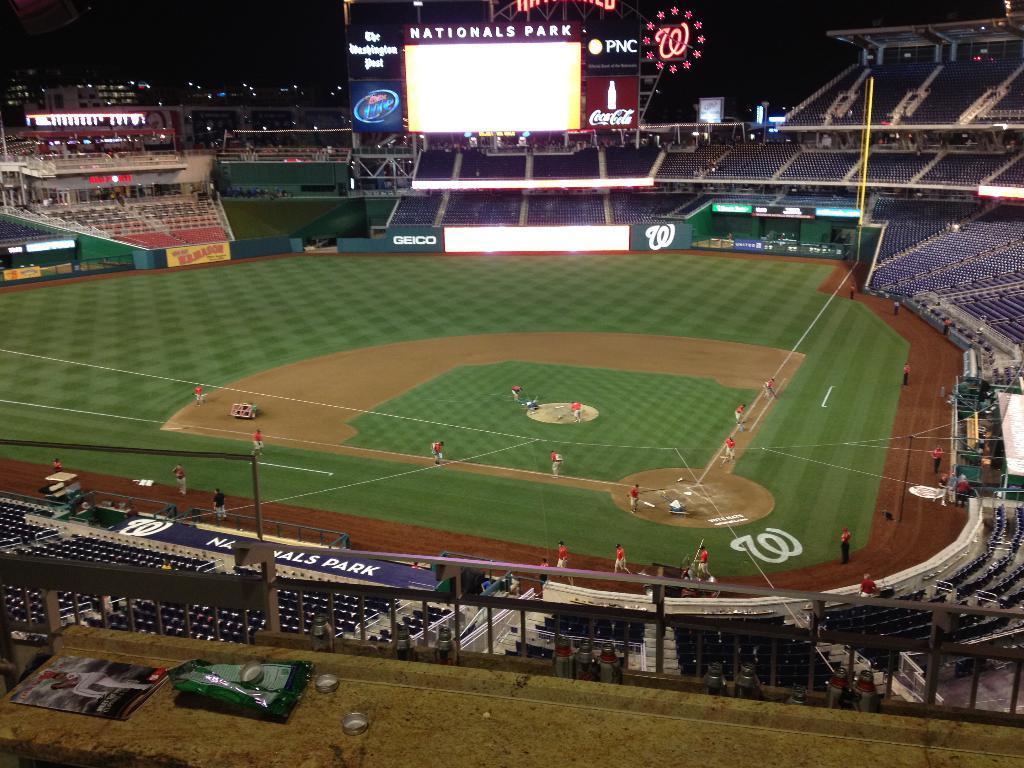Please provide a concise description of this image. This picture looks like a stadium, in this image we can see a few people on the ground, there are some chairs, boards, poles and a screen, also we can see the background is dark. 